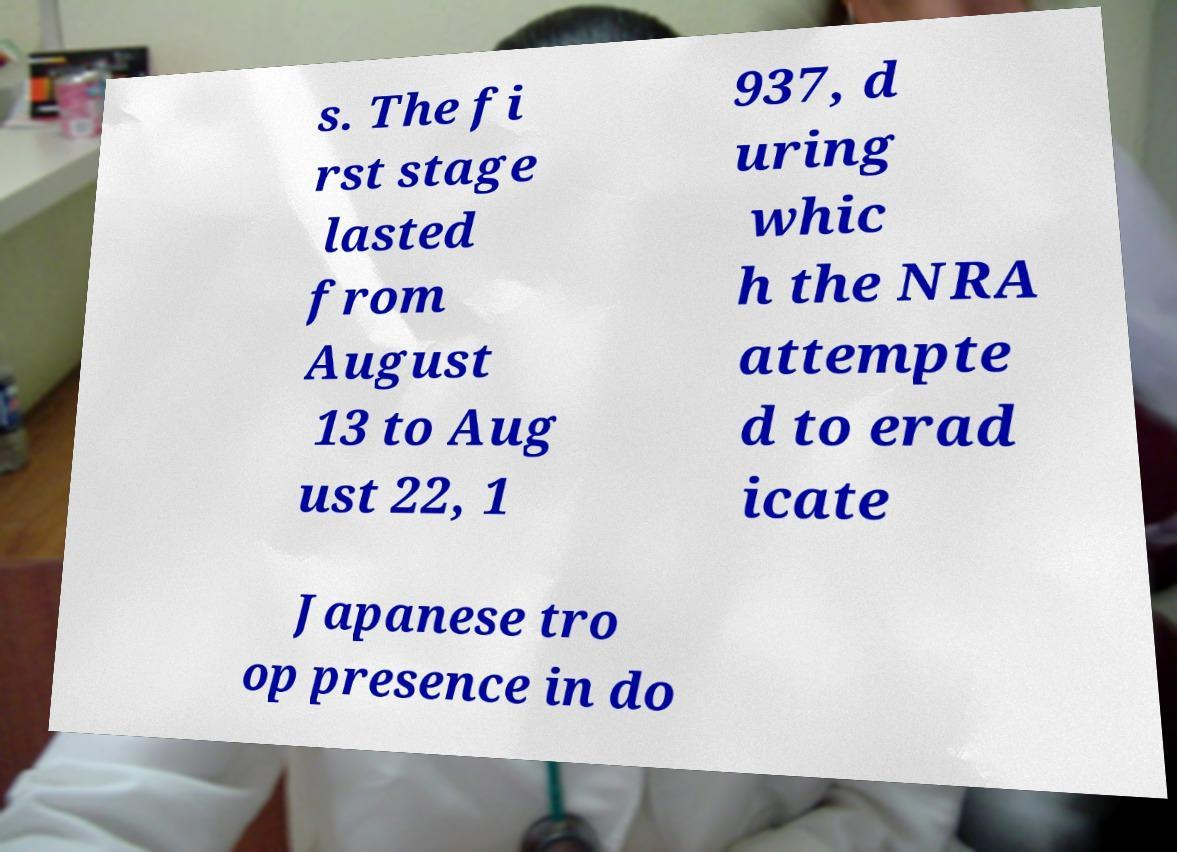Please identify and transcribe the text found in this image. s. The fi rst stage lasted from August 13 to Aug ust 22, 1 937, d uring whic h the NRA attempte d to erad icate Japanese tro op presence in do 